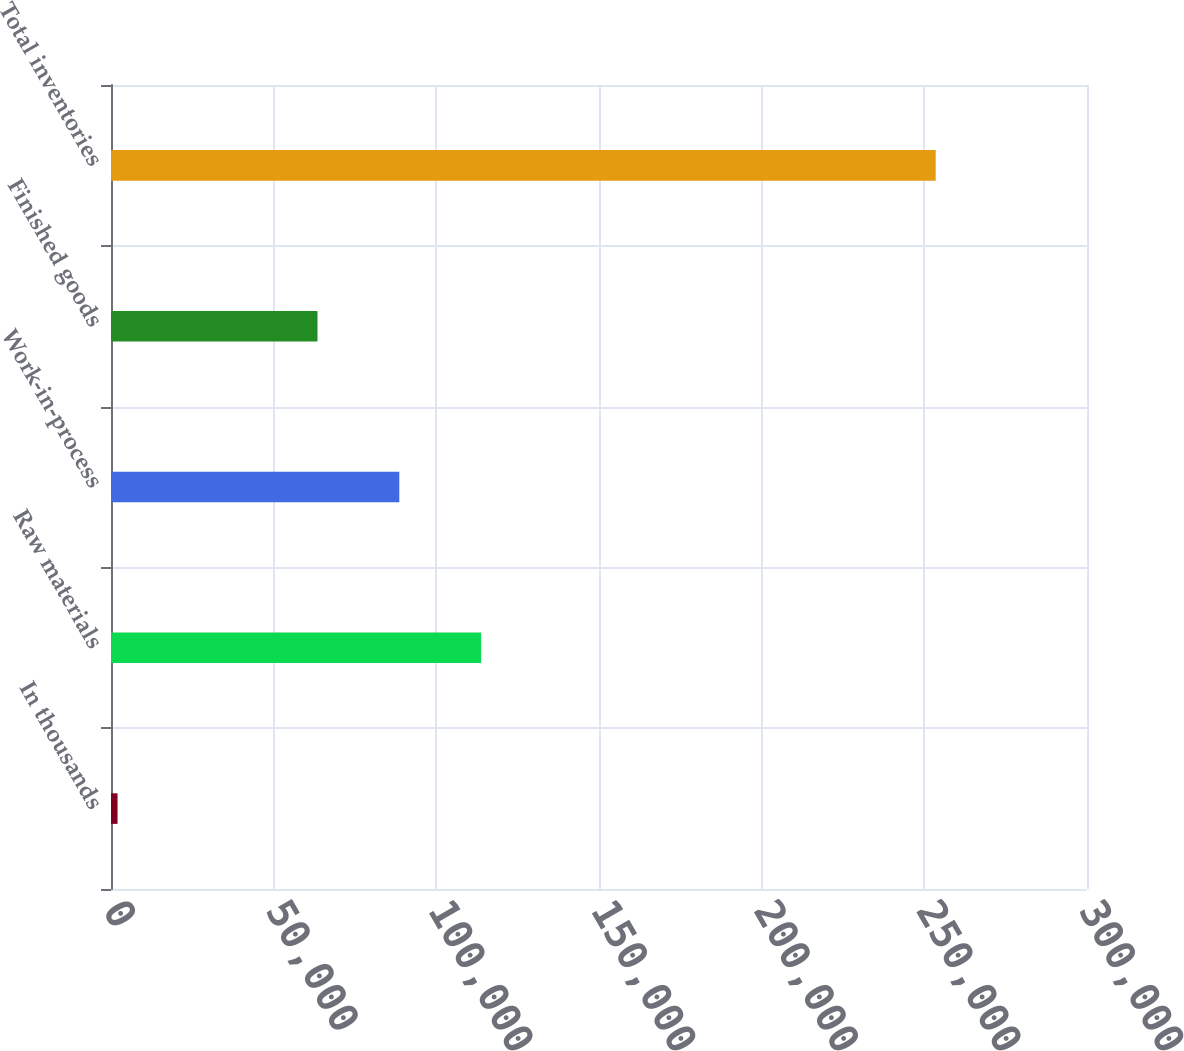<chart> <loc_0><loc_0><loc_500><loc_500><bar_chart><fcel>In thousands<fcel>Raw materials<fcel>Work-in-process<fcel>Finished goods<fcel>Total inventories<nl><fcel>2010<fcel>113765<fcel>88617.1<fcel>63469<fcel>253491<nl></chart> 